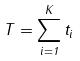Convert formula to latex. <formula><loc_0><loc_0><loc_500><loc_500>T = \sum _ { i = 1 } ^ { K } t _ { i }</formula> 